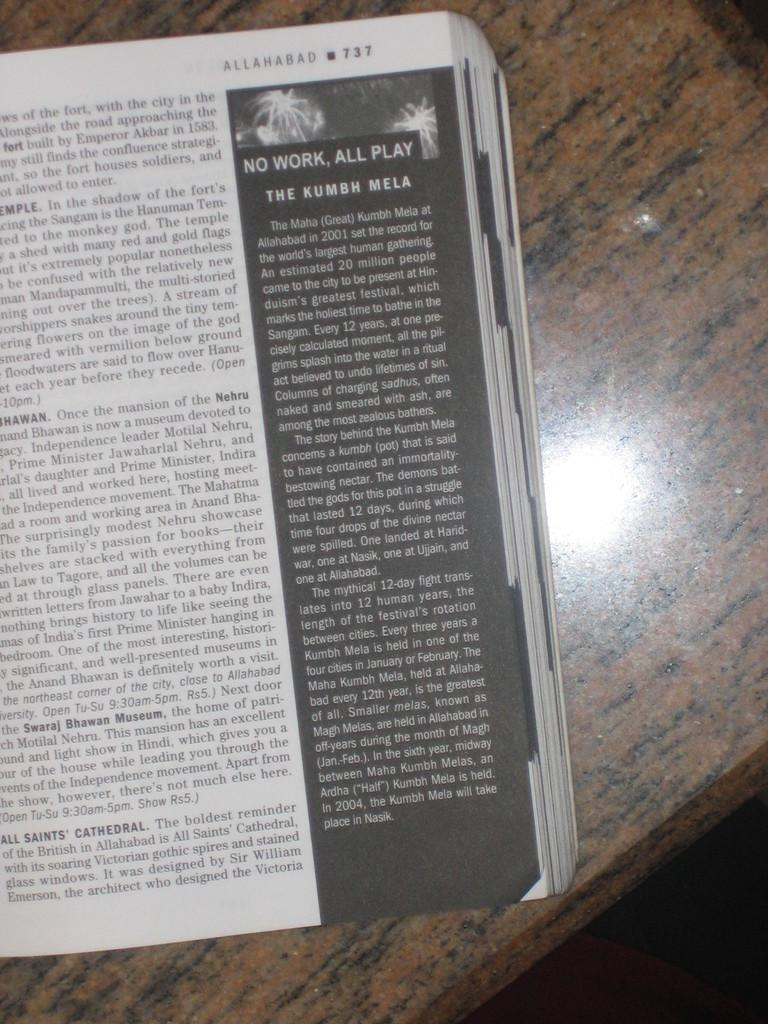<image>
Give a short and clear explanation of the subsequent image. a guidebook to Allahabad is on a marble table 